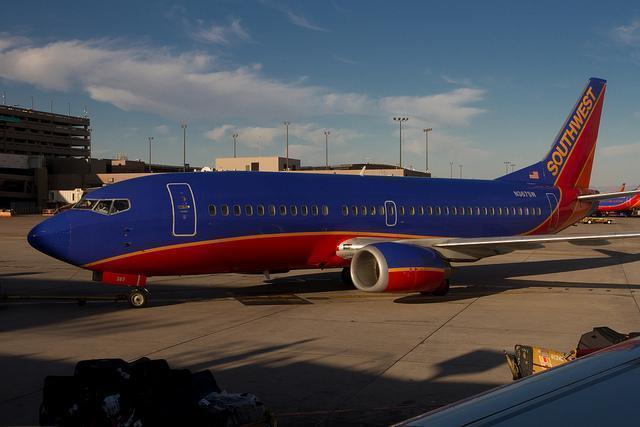What is the blue plane used for?
Select the accurate response from the four choices given to answer the question.
Options: Commercial travel, cargo shipping, military exercises, racing. Commercial travel. 